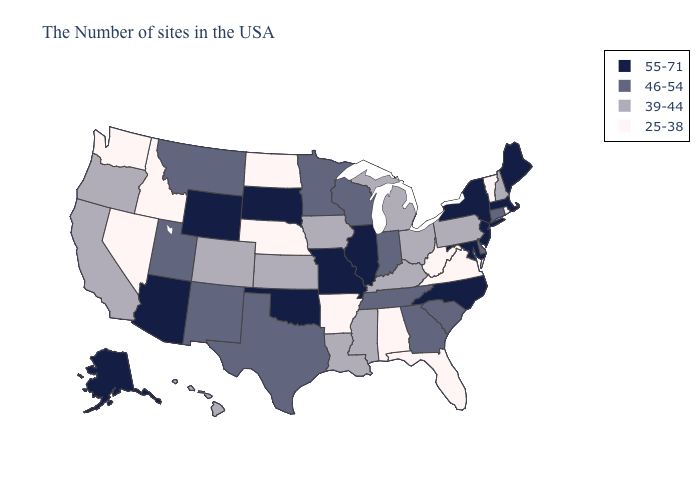Does New Jersey have the lowest value in the USA?
Give a very brief answer. No. What is the value of Florida?
Concise answer only. 25-38. Does Iowa have the highest value in the MidWest?
Keep it brief. No. Does Illinois have the highest value in the MidWest?
Give a very brief answer. Yes. Does Minnesota have a lower value than Maine?
Quick response, please. Yes. What is the value of Maryland?
Give a very brief answer. 55-71. How many symbols are there in the legend?
Concise answer only. 4. Name the states that have a value in the range 46-54?
Be succinct. Connecticut, Delaware, South Carolina, Georgia, Indiana, Tennessee, Wisconsin, Minnesota, Texas, New Mexico, Utah, Montana. Name the states that have a value in the range 39-44?
Answer briefly. New Hampshire, Pennsylvania, Ohio, Michigan, Kentucky, Mississippi, Louisiana, Iowa, Kansas, Colorado, California, Oregon, Hawaii. Does Nebraska have the same value as Florida?
Quick response, please. Yes. Does Alabama have the lowest value in the South?
Keep it brief. Yes. Name the states that have a value in the range 46-54?
Short answer required. Connecticut, Delaware, South Carolina, Georgia, Indiana, Tennessee, Wisconsin, Minnesota, Texas, New Mexico, Utah, Montana. Name the states that have a value in the range 25-38?
Keep it brief. Rhode Island, Vermont, Virginia, West Virginia, Florida, Alabama, Arkansas, Nebraska, North Dakota, Idaho, Nevada, Washington. What is the value of Oregon?
Be succinct. 39-44. Name the states that have a value in the range 55-71?
Short answer required. Maine, Massachusetts, New York, New Jersey, Maryland, North Carolina, Illinois, Missouri, Oklahoma, South Dakota, Wyoming, Arizona, Alaska. 